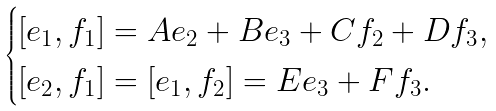Convert formula to latex. <formula><loc_0><loc_0><loc_500><loc_500>\begin{cases} [ e _ { 1 } , f _ { 1 } ] = A e _ { 2 } + B e _ { 3 } + C f _ { 2 } + D f _ { 3 } , \\ [ e _ { 2 } , f _ { 1 } ] = [ e _ { 1 } , f _ { 2 } ] = E e _ { 3 } + F f _ { 3 } . \end{cases}</formula> 